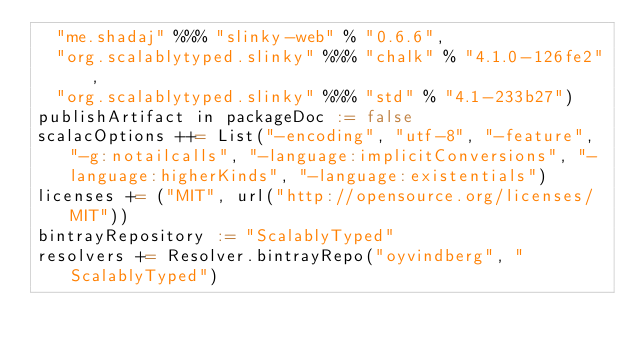<code> <loc_0><loc_0><loc_500><loc_500><_Scala_>  "me.shadaj" %%% "slinky-web" % "0.6.6",
  "org.scalablytyped.slinky" %%% "chalk" % "4.1.0-126fe2",
  "org.scalablytyped.slinky" %%% "std" % "4.1-233b27")
publishArtifact in packageDoc := false
scalacOptions ++= List("-encoding", "utf-8", "-feature", "-g:notailcalls", "-language:implicitConversions", "-language:higherKinds", "-language:existentials")
licenses += ("MIT", url("http://opensource.org/licenses/MIT"))
bintrayRepository := "ScalablyTyped"
resolvers += Resolver.bintrayRepo("oyvindberg", "ScalablyTyped")
</code> 